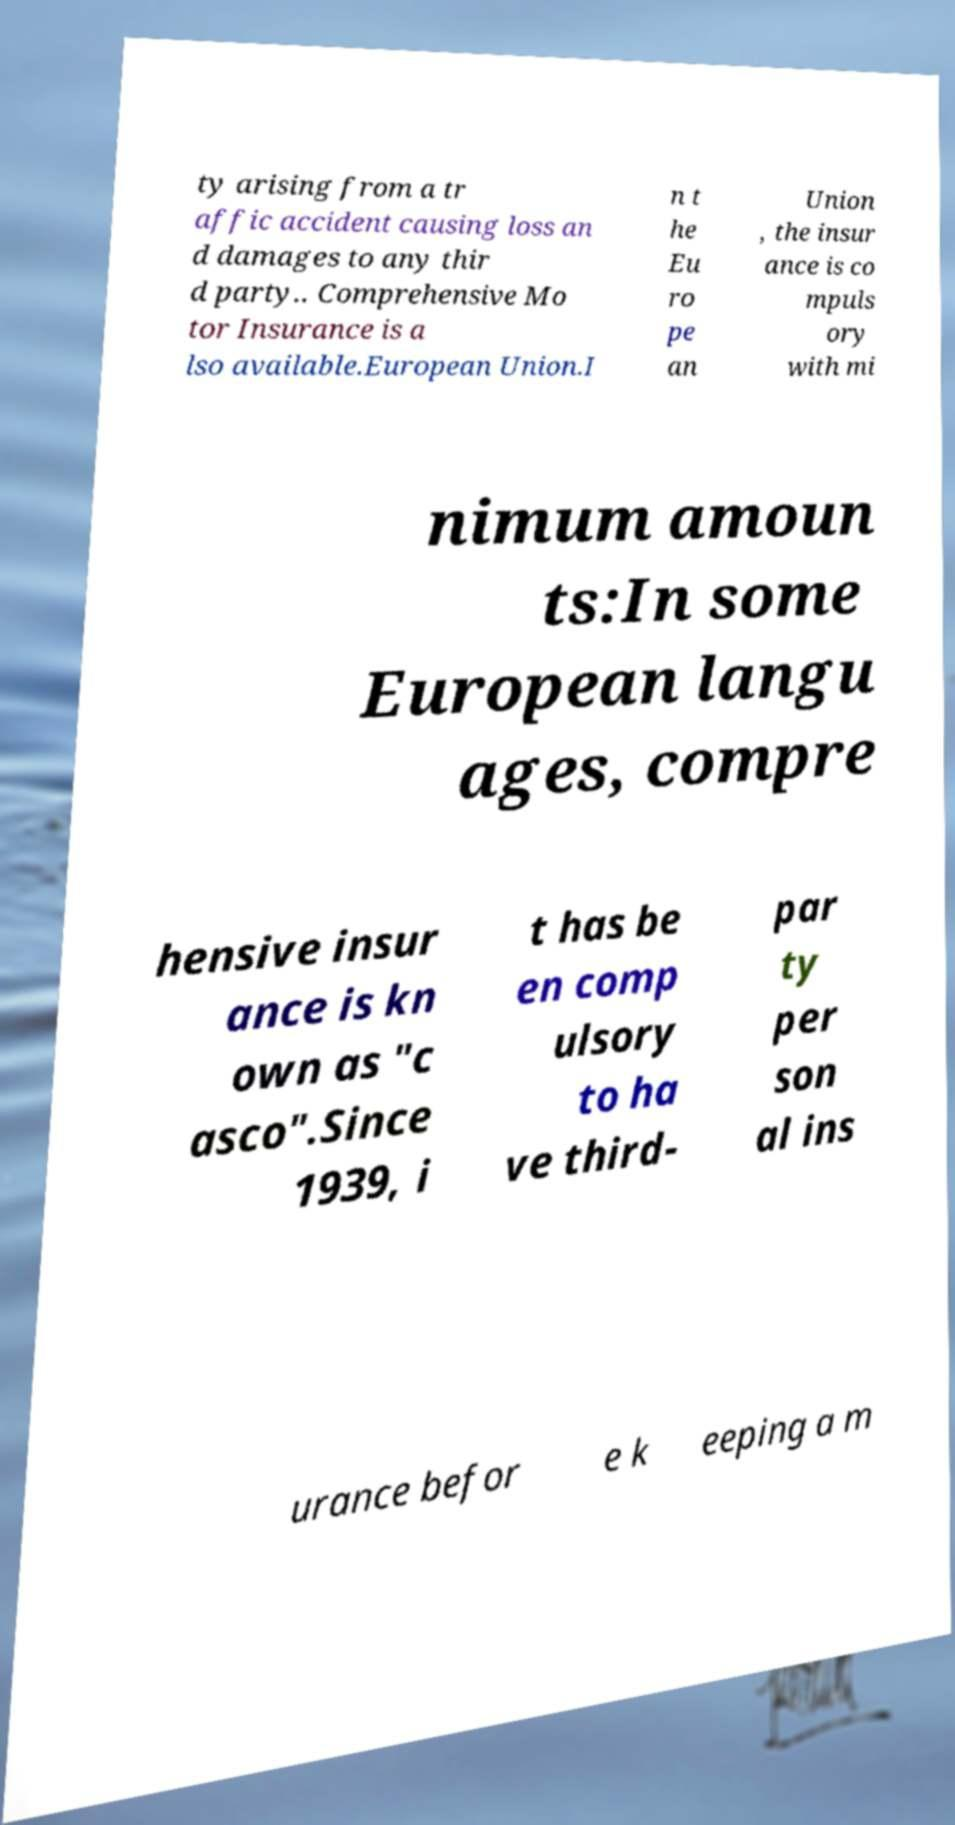Please identify and transcribe the text found in this image. ty arising from a tr affic accident causing loss an d damages to any thir d party.. Comprehensive Mo tor Insurance is a lso available.European Union.I n t he Eu ro pe an Union , the insur ance is co mpuls ory with mi nimum amoun ts:In some European langu ages, compre hensive insur ance is kn own as "c asco".Since 1939, i t has be en comp ulsory to ha ve third- par ty per son al ins urance befor e k eeping a m 